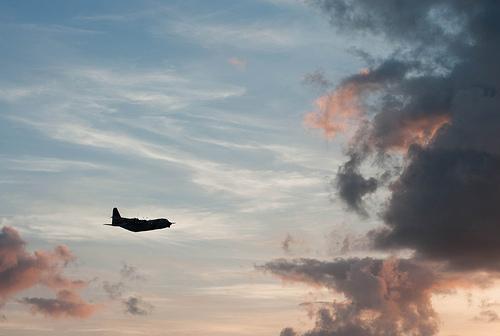How many airplanes?
Give a very brief answer. 1. 